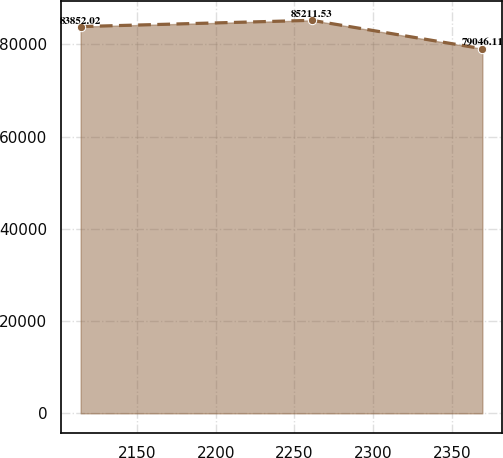<chart> <loc_0><loc_0><loc_500><loc_500><line_chart><ecel><fcel>Unnamed: 1<nl><fcel>2114.25<fcel>83852<nl><fcel>2261.03<fcel>85211.5<nl><fcel>2369.31<fcel>79046.1<nl></chart> 